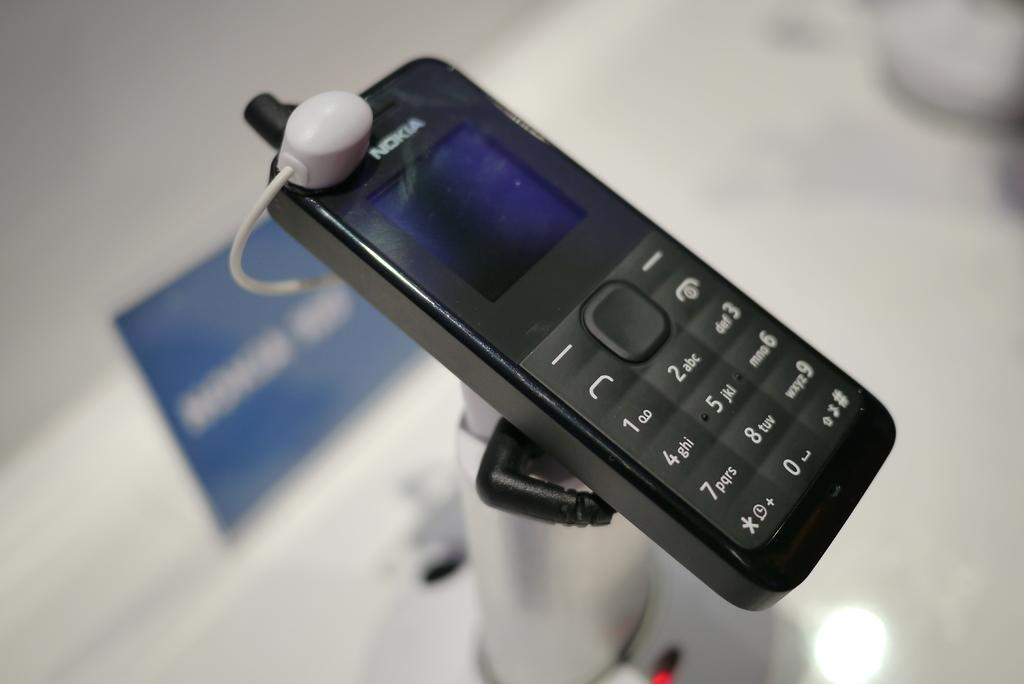What electronic device is visible in the image? There is a mobile phone in the image. What feature does the mobile phone have? The mobile phone has a connector. How is the mobile phone positioned in the image? The mobile phone is placed on a stand. What other object can be seen in the image? There is a name board in the image. Where is the name board located? The name board is on a surface. What type of musical instrument is being played on the island in the image? There is no musical instrument or island present in the image. 